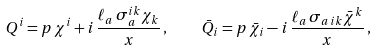Convert formula to latex. <formula><loc_0><loc_0><loc_500><loc_500>Q ^ { i } = p \, \chi ^ { i } + i \, \frac { \ell _ { a } \, \sigma _ { a } ^ { i k } \chi _ { k } } { x } \, , \quad \bar { Q } _ { i } = p \, \bar { \chi } _ { i } - i \, \frac { \ell _ { a } \, \sigma _ { a \, i k } \bar { \chi } ^ { k } } { x } \, ,</formula> 